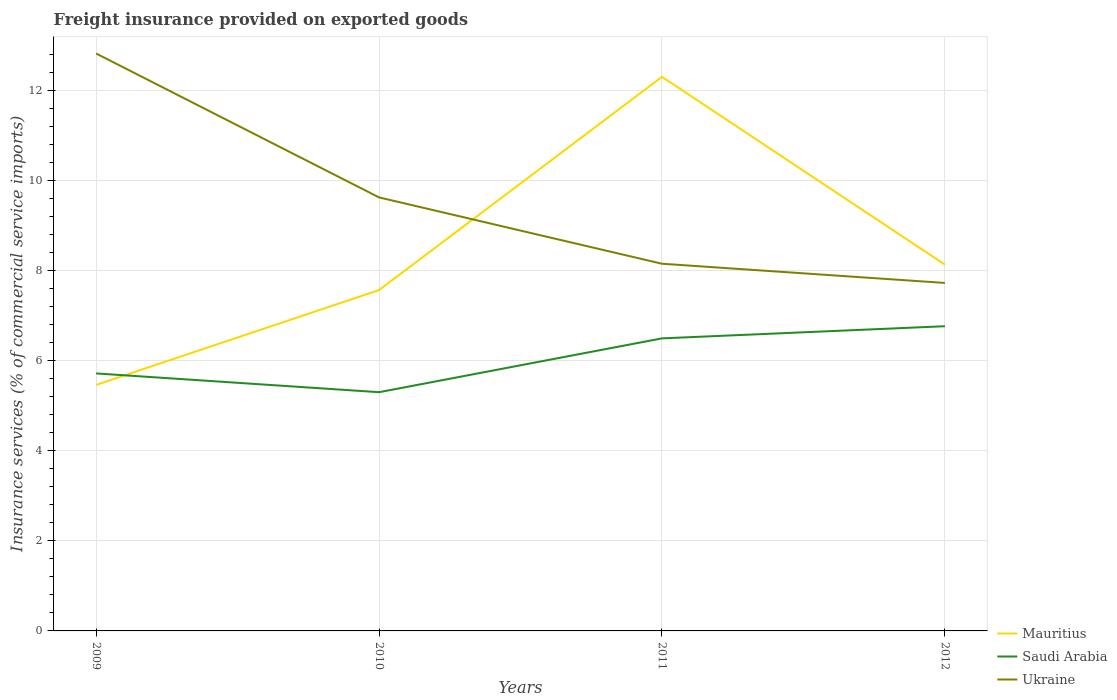How many different coloured lines are there?
Your response must be concise. 3. Is the number of lines equal to the number of legend labels?
Your answer should be very brief. Yes. Across all years, what is the maximum freight insurance provided on exported goods in Saudi Arabia?
Ensure brevity in your answer.  5.3. What is the total freight insurance provided on exported goods in Ukraine in the graph?
Your answer should be compact. 4.67. What is the difference between the highest and the second highest freight insurance provided on exported goods in Ukraine?
Your answer should be compact. 5.09. What is the difference between the highest and the lowest freight insurance provided on exported goods in Mauritius?
Provide a succinct answer. 1. Is the freight insurance provided on exported goods in Saudi Arabia strictly greater than the freight insurance provided on exported goods in Mauritius over the years?
Provide a short and direct response. No. Does the graph contain any zero values?
Offer a very short reply. No. How are the legend labels stacked?
Your answer should be very brief. Vertical. What is the title of the graph?
Provide a succinct answer. Freight insurance provided on exported goods. Does "High income" appear as one of the legend labels in the graph?
Keep it short and to the point. No. What is the label or title of the X-axis?
Offer a very short reply. Years. What is the label or title of the Y-axis?
Provide a short and direct response. Insurance services (% of commercial service imports). What is the Insurance services (% of commercial service imports) of Mauritius in 2009?
Your response must be concise. 5.46. What is the Insurance services (% of commercial service imports) of Saudi Arabia in 2009?
Provide a succinct answer. 5.72. What is the Insurance services (% of commercial service imports) of Ukraine in 2009?
Your answer should be compact. 12.82. What is the Insurance services (% of commercial service imports) of Mauritius in 2010?
Provide a succinct answer. 7.57. What is the Insurance services (% of commercial service imports) of Saudi Arabia in 2010?
Your answer should be very brief. 5.3. What is the Insurance services (% of commercial service imports) of Ukraine in 2010?
Your answer should be very brief. 9.62. What is the Insurance services (% of commercial service imports) in Mauritius in 2011?
Your response must be concise. 12.3. What is the Insurance services (% of commercial service imports) in Saudi Arabia in 2011?
Your answer should be compact. 6.49. What is the Insurance services (% of commercial service imports) in Ukraine in 2011?
Give a very brief answer. 8.15. What is the Insurance services (% of commercial service imports) of Mauritius in 2012?
Give a very brief answer. 8.13. What is the Insurance services (% of commercial service imports) in Saudi Arabia in 2012?
Keep it short and to the point. 6.76. What is the Insurance services (% of commercial service imports) in Ukraine in 2012?
Provide a short and direct response. 7.72. Across all years, what is the maximum Insurance services (% of commercial service imports) of Mauritius?
Make the answer very short. 12.3. Across all years, what is the maximum Insurance services (% of commercial service imports) of Saudi Arabia?
Your answer should be compact. 6.76. Across all years, what is the maximum Insurance services (% of commercial service imports) in Ukraine?
Your response must be concise. 12.82. Across all years, what is the minimum Insurance services (% of commercial service imports) in Mauritius?
Offer a very short reply. 5.46. Across all years, what is the minimum Insurance services (% of commercial service imports) of Saudi Arabia?
Your answer should be very brief. 5.3. Across all years, what is the minimum Insurance services (% of commercial service imports) in Ukraine?
Provide a succinct answer. 7.72. What is the total Insurance services (% of commercial service imports) of Mauritius in the graph?
Offer a very short reply. 33.46. What is the total Insurance services (% of commercial service imports) of Saudi Arabia in the graph?
Your answer should be compact. 24.27. What is the total Insurance services (% of commercial service imports) of Ukraine in the graph?
Give a very brief answer. 38.32. What is the difference between the Insurance services (% of commercial service imports) of Mauritius in 2009 and that in 2010?
Ensure brevity in your answer.  -2.11. What is the difference between the Insurance services (% of commercial service imports) of Saudi Arabia in 2009 and that in 2010?
Your answer should be compact. 0.42. What is the difference between the Insurance services (% of commercial service imports) in Ukraine in 2009 and that in 2010?
Your answer should be compact. 3.19. What is the difference between the Insurance services (% of commercial service imports) of Mauritius in 2009 and that in 2011?
Provide a succinct answer. -6.84. What is the difference between the Insurance services (% of commercial service imports) of Saudi Arabia in 2009 and that in 2011?
Provide a short and direct response. -0.78. What is the difference between the Insurance services (% of commercial service imports) in Ukraine in 2009 and that in 2011?
Make the answer very short. 4.67. What is the difference between the Insurance services (% of commercial service imports) in Mauritius in 2009 and that in 2012?
Offer a very short reply. -2.67. What is the difference between the Insurance services (% of commercial service imports) in Saudi Arabia in 2009 and that in 2012?
Your answer should be very brief. -1.05. What is the difference between the Insurance services (% of commercial service imports) in Ukraine in 2009 and that in 2012?
Provide a succinct answer. 5.09. What is the difference between the Insurance services (% of commercial service imports) in Mauritius in 2010 and that in 2011?
Provide a short and direct response. -4.73. What is the difference between the Insurance services (% of commercial service imports) of Saudi Arabia in 2010 and that in 2011?
Your response must be concise. -1.19. What is the difference between the Insurance services (% of commercial service imports) of Ukraine in 2010 and that in 2011?
Give a very brief answer. 1.47. What is the difference between the Insurance services (% of commercial service imports) of Mauritius in 2010 and that in 2012?
Ensure brevity in your answer.  -0.56. What is the difference between the Insurance services (% of commercial service imports) of Saudi Arabia in 2010 and that in 2012?
Offer a terse response. -1.46. What is the difference between the Insurance services (% of commercial service imports) in Ukraine in 2010 and that in 2012?
Offer a terse response. 1.9. What is the difference between the Insurance services (% of commercial service imports) of Mauritius in 2011 and that in 2012?
Your answer should be very brief. 4.17. What is the difference between the Insurance services (% of commercial service imports) of Saudi Arabia in 2011 and that in 2012?
Your answer should be very brief. -0.27. What is the difference between the Insurance services (% of commercial service imports) in Ukraine in 2011 and that in 2012?
Make the answer very short. 0.43. What is the difference between the Insurance services (% of commercial service imports) of Mauritius in 2009 and the Insurance services (% of commercial service imports) of Saudi Arabia in 2010?
Provide a succinct answer. 0.16. What is the difference between the Insurance services (% of commercial service imports) of Mauritius in 2009 and the Insurance services (% of commercial service imports) of Ukraine in 2010?
Keep it short and to the point. -4.16. What is the difference between the Insurance services (% of commercial service imports) of Saudi Arabia in 2009 and the Insurance services (% of commercial service imports) of Ukraine in 2010?
Offer a very short reply. -3.91. What is the difference between the Insurance services (% of commercial service imports) of Mauritius in 2009 and the Insurance services (% of commercial service imports) of Saudi Arabia in 2011?
Keep it short and to the point. -1.03. What is the difference between the Insurance services (% of commercial service imports) in Mauritius in 2009 and the Insurance services (% of commercial service imports) in Ukraine in 2011?
Ensure brevity in your answer.  -2.69. What is the difference between the Insurance services (% of commercial service imports) in Saudi Arabia in 2009 and the Insurance services (% of commercial service imports) in Ukraine in 2011?
Keep it short and to the point. -2.43. What is the difference between the Insurance services (% of commercial service imports) of Mauritius in 2009 and the Insurance services (% of commercial service imports) of Saudi Arabia in 2012?
Your answer should be very brief. -1.3. What is the difference between the Insurance services (% of commercial service imports) of Mauritius in 2009 and the Insurance services (% of commercial service imports) of Ukraine in 2012?
Provide a succinct answer. -2.26. What is the difference between the Insurance services (% of commercial service imports) in Saudi Arabia in 2009 and the Insurance services (% of commercial service imports) in Ukraine in 2012?
Offer a terse response. -2.01. What is the difference between the Insurance services (% of commercial service imports) of Mauritius in 2010 and the Insurance services (% of commercial service imports) of Saudi Arabia in 2011?
Provide a short and direct response. 1.07. What is the difference between the Insurance services (% of commercial service imports) in Mauritius in 2010 and the Insurance services (% of commercial service imports) in Ukraine in 2011?
Keep it short and to the point. -0.58. What is the difference between the Insurance services (% of commercial service imports) in Saudi Arabia in 2010 and the Insurance services (% of commercial service imports) in Ukraine in 2011?
Your response must be concise. -2.85. What is the difference between the Insurance services (% of commercial service imports) of Mauritius in 2010 and the Insurance services (% of commercial service imports) of Saudi Arabia in 2012?
Your response must be concise. 0.8. What is the difference between the Insurance services (% of commercial service imports) in Mauritius in 2010 and the Insurance services (% of commercial service imports) in Ukraine in 2012?
Make the answer very short. -0.16. What is the difference between the Insurance services (% of commercial service imports) in Saudi Arabia in 2010 and the Insurance services (% of commercial service imports) in Ukraine in 2012?
Provide a short and direct response. -2.43. What is the difference between the Insurance services (% of commercial service imports) in Mauritius in 2011 and the Insurance services (% of commercial service imports) in Saudi Arabia in 2012?
Your answer should be very brief. 5.54. What is the difference between the Insurance services (% of commercial service imports) of Mauritius in 2011 and the Insurance services (% of commercial service imports) of Ukraine in 2012?
Offer a very short reply. 4.58. What is the difference between the Insurance services (% of commercial service imports) in Saudi Arabia in 2011 and the Insurance services (% of commercial service imports) in Ukraine in 2012?
Offer a terse response. -1.23. What is the average Insurance services (% of commercial service imports) of Mauritius per year?
Ensure brevity in your answer.  8.36. What is the average Insurance services (% of commercial service imports) of Saudi Arabia per year?
Give a very brief answer. 6.07. What is the average Insurance services (% of commercial service imports) of Ukraine per year?
Your answer should be compact. 9.58. In the year 2009, what is the difference between the Insurance services (% of commercial service imports) in Mauritius and Insurance services (% of commercial service imports) in Saudi Arabia?
Provide a short and direct response. -0.25. In the year 2009, what is the difference between the Insurance services (% of commercial service imports) in Mauritius and Insurance services (% of commercial service imports) in Ukraine?
Your answer should be compact. -7.36. In the year 2009, what is the difference between the Insurance services (% of commercial service imports) in Saudi Arabia and Insurance services (% of commercial service imports) in Ukraine?
Offer a very short reply. -7.1. In the year 2010, what is the difference between the Insurance services (% of commercial service imports) in Mauritius and Insurance services (% of commercial service imports) in Saudi Arabia?
Your answer should be compact. 2.27. In the year 2010, what is the difference between the Insurance services (% of commercial service imports) in Mauritius and Insurance services (% of commercial service imports) in Ukraine?
Make the answer very short. -2.06. In the year 2010, what is the difference between the Insurance services (% of commercial service imports) of Saudi Arabia and Insurance services (% of commercial service imports) of Ukraine?
Make the answer very short. -4.32. In the year 2011, what is the difference between the Insurance services (% of commercial service imports) in Mauritius and Insurance services (% of commercial service imports) in Saudi Arabia?
Give a very brief answer. 5.81. In the year 2011, what is the difference between the Insurance services (% of commercial service imports) of Mauritius and Insurance services (% of commercial service imports) of Ukraine?
Keep it short and to the point. 4.15. In the year 2011, what is the difference between the Insurance services (% of commercial service imports) of Saudi Arabia and Insurance services (% of commercial service imports) of Ukraine?
Give a very brief answer. -1.66. In the year 2012, what is the difference between the Insurance services (% of commercial service imports) in Mauritius and Insurance services (% of commercial service imports) in Saudi Arabia?
Offer a very short reply. 1.37. In the year 2012, what is the difference between the Insurance services (% of commercial service imports) of Mauritius and Insurance services (% of commercial service imports) of Ukraine?
Provide a succinct answer. 0.41. In the year 2012, what is the difference between the Insurance services (% of commercial service imports) of Saudi Arabia and Insurance services (% of commercial service imports) of Ukraine?
Ensure brevity in your answer.  -0.96. What is the ratio of the Insurance services (% of commercial service imports) of Mauritius in 2009 to that in 2010?
Offer a very short reply. 0.72. What is the ratio of the Insurance services (% of commercial service imports) of Saudi Arabia in 2009 to that in 2010?
Offer a terse response. 1.08. What is the ratio of the Insurance services (% of commercial service imports) of Ukraine in 2009 to that in 2010?
Your answer should be very brief. 1.33. What is the ratio of the Insurance services (% of commercial service imports) of Mauritius in 2009 to that in 2011?
Your answer should be very brief. 0.44. What is the ratio of the Insurance services (% of commercial service imports) of Saudi Arabia in 2009 to that in 2011?
Give a very brief answer. 0.88. What is the ratio of the Insurance services (% of commercial service imports) of Ukraine in 2009 to that in 2011?
Keep it short and to the point. 1.57. What is the ratio of the Insurance services (% of commercial service imports) of Mauritius in 2009 to that in 2012?
Provide a short and direct response. 0.67. What is the ratio of the Insurance services (% of commercial service imports) in Saudi Arabia in 2009 to that in 2012?
Your answer should be compact. 0.85. What is the ratio of the Insurance services (% of commercial service imports) of Ukraine in 2009 to that in 2012?
Offer a very short reply. 1.66. What is the ratio of the Insurance services (% of commercial service imports) in Mauritius in 2010 to that in 2011?
Provide a succinct answer. 0.62. What is the ratio of the Insurance services (% of commercial service imports) of Saudi Arabia in 2010 to that in 2011?
Give a very brief answer. 0.82. What is the ratio of the Insurance services (% of commercial service imports) in Ukraine in 2010 to that in 2011?
Provide a short and direct response. 1.18. What is the ratio of the Insurance services (% of commercial service imports) in Mauritius in 2010 to that in 2012?
Your answer should be very brief. 0.93. What is the ratio of the Insurance services (% of commercial service imports) of Saudi Arabia in 2010 to that in 2012?
Ensure brevity in your answer.  0.78. What is the ratio of the Insurance services (% of commercial service imports) of Ukraine in 2010 to that in 2012?
Your response must be concise. 1.25. What is the ratio of the Insurance services (% of commercial service imports) of Mauritius in 2011 to that in 2012?
Your answer should be very brief. 1.51. What is the ratio of the Insurance services (% of commercial service imports) of Saudi Arabia in 2011 to that in 2012?
Keep it short and to the point. 0.96. What is the ratio of the Insurance services (% of commercial service imports) in Ukraine in 2011 to that in 2012?
Your answer should be very brief. 1.06. What is the difference between the highest and the second highest Insurance services (% of commercial service imports) in Mauritius?
Provide a succinct answer. 4.17. What is the difference between the highest and the second highest Insurance services (% of commercial service imports) in Saudi Arabia?
Your response must be concise. 0.27. What is the difference between the highest and the second highest Insurance services (% of commercial service imports) of Ukraine?
Offer a very short reply. 3.19. What is the difference between the highest and the lowest Insurance services (% of commercial service imports) of Mauritius?
Keep it short and to the point. 6.84. What is the difference between the highest and the lowest Insurance services (% of commercial service imports) in Saudi Arabia?
Provide a succinct answer. 1.46. What is the difference between the highest and the lowest Insurance services (% of commercial service imports) in Ukraine?
Provide a succinct answer. 5.09. 